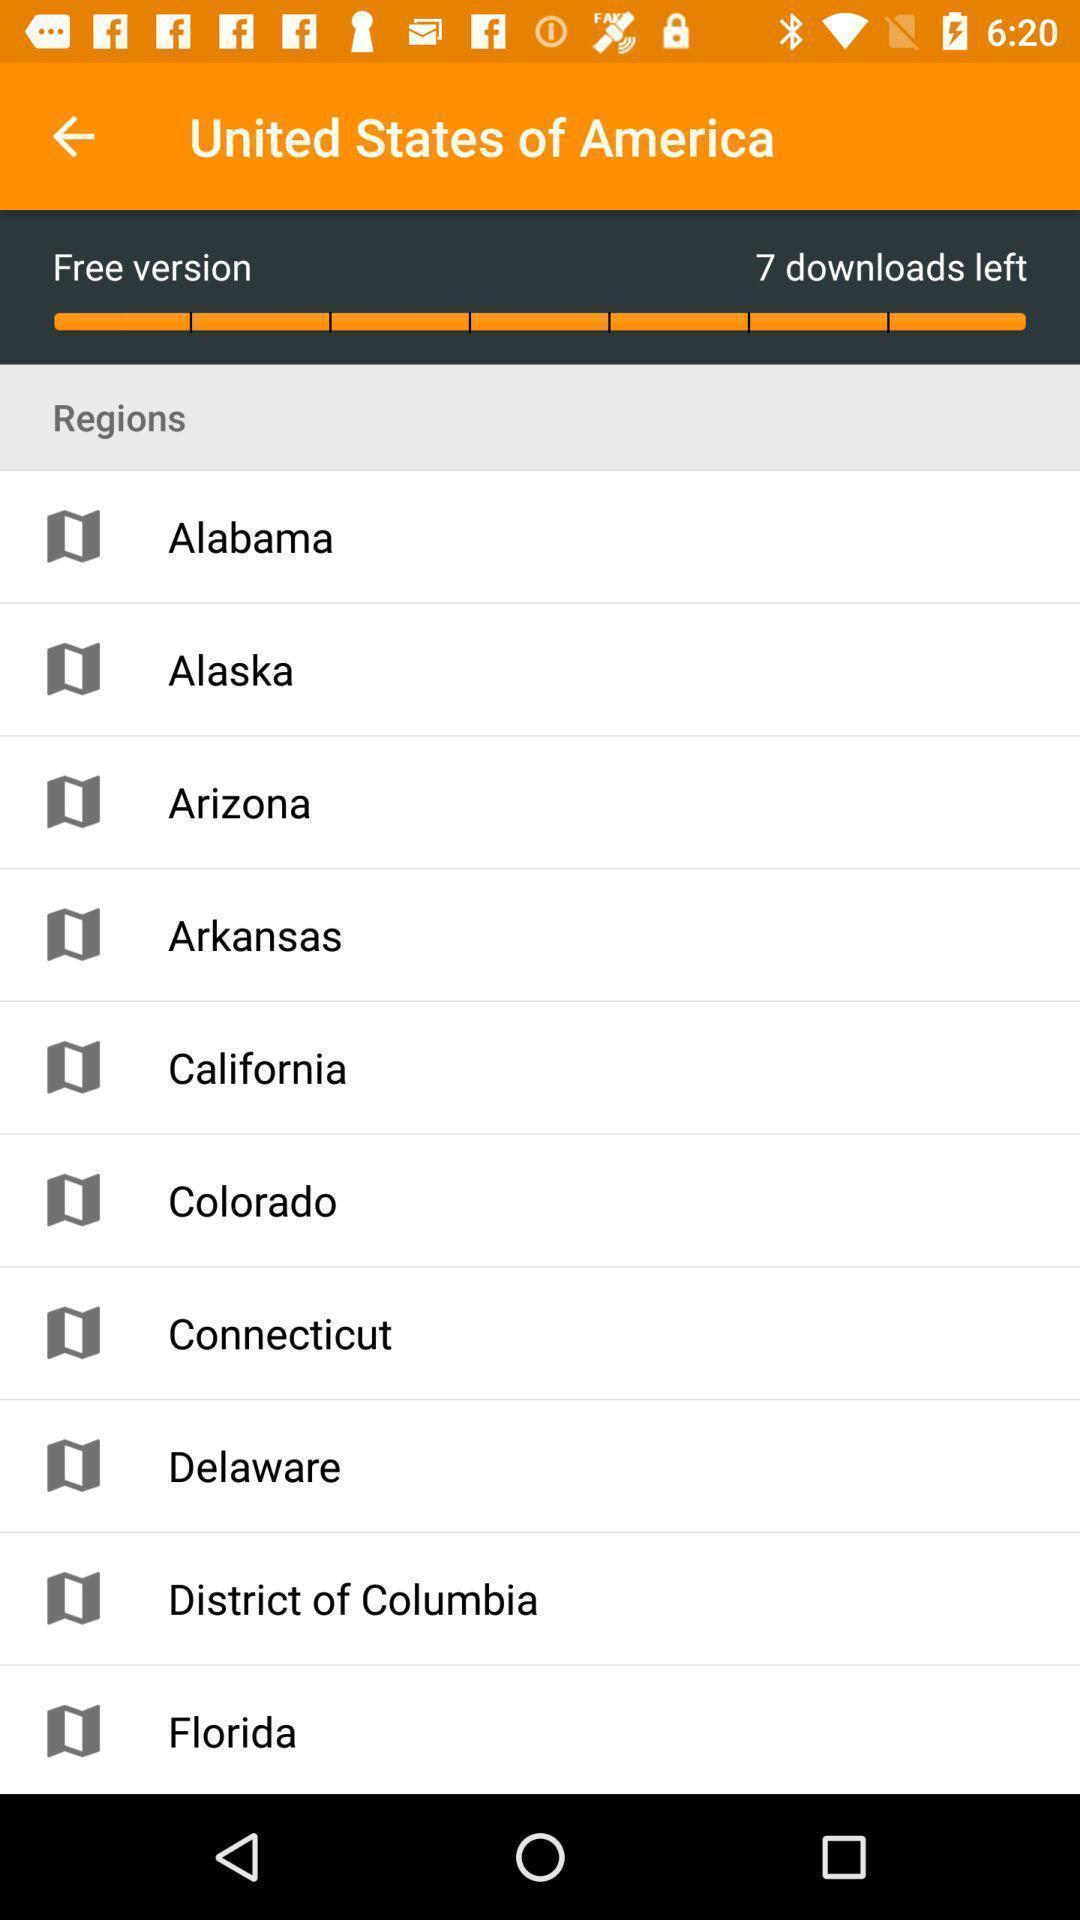Provide a textual representation of this image. Page showing variety of places. 